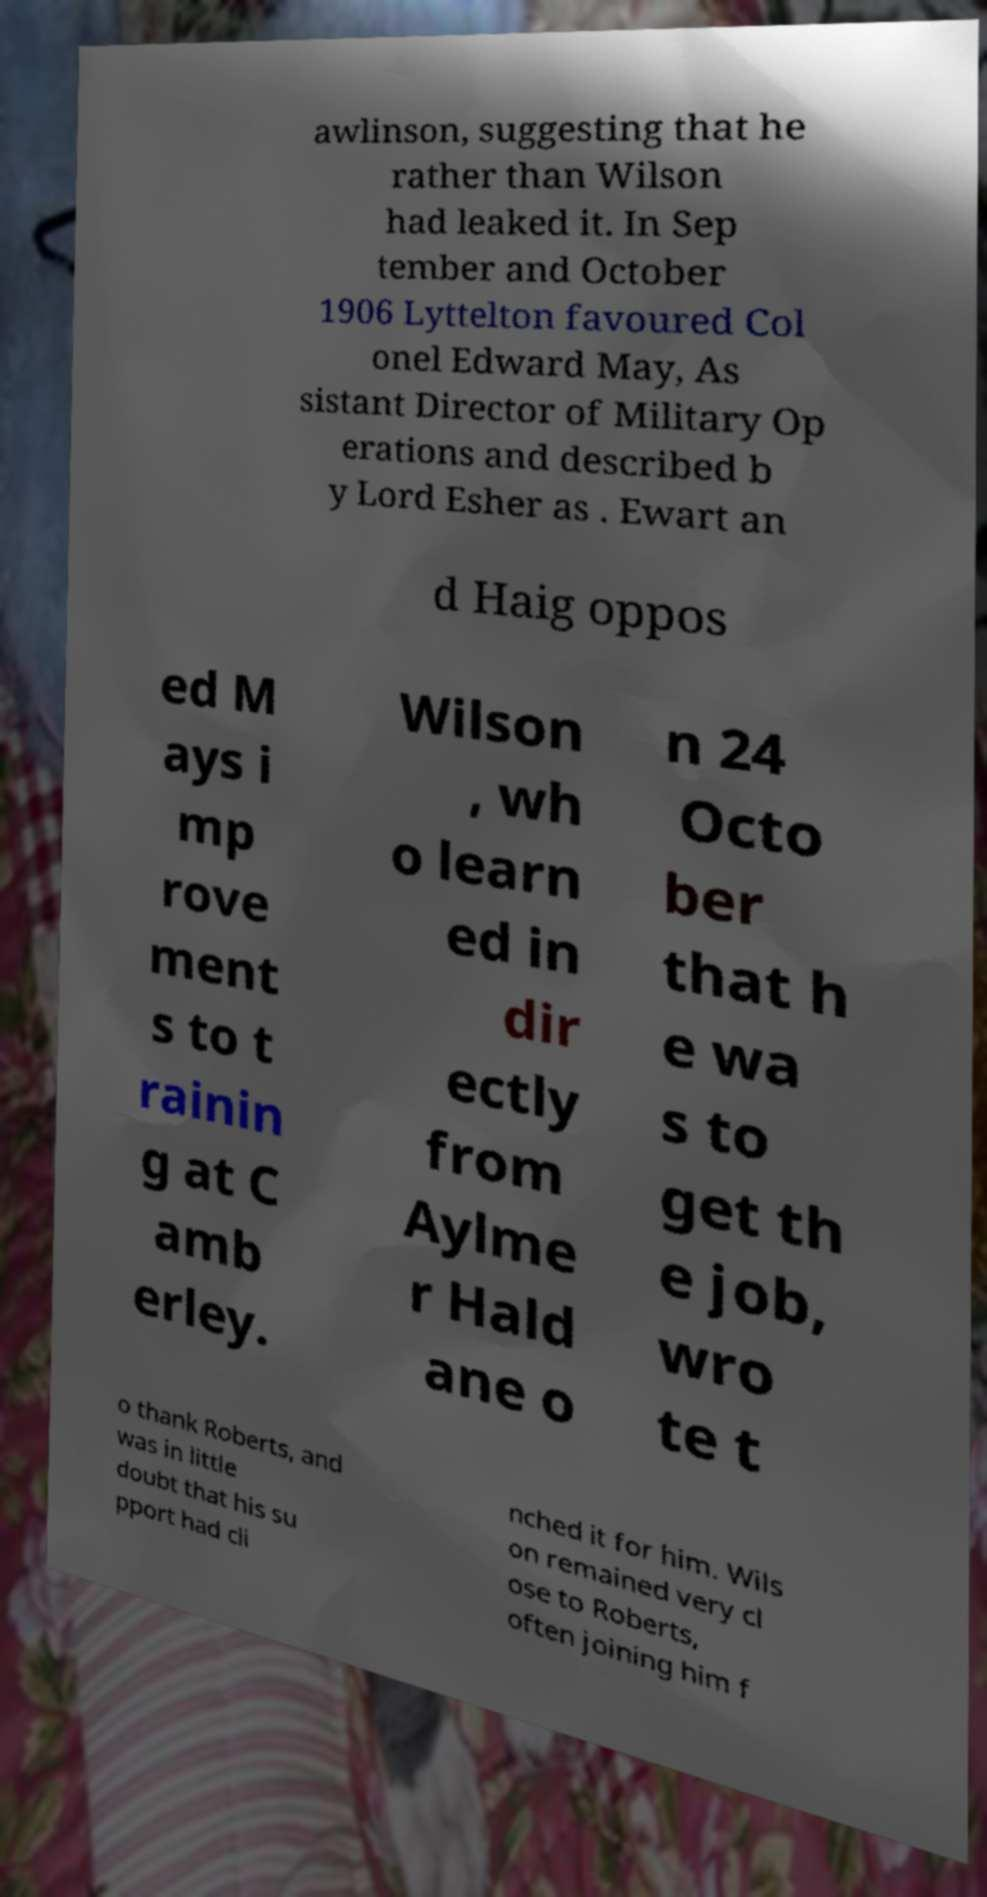Can you read and provide the text displayed in the image?This photo seems to have some interesting text. Can you extract and type it out for me? awlinson, suggesting that he rather than Wilson had leaked it. In Sep tember and October 1906 Lyttelton favoured Col onel Edward May, As sistant Director of Military Op erations and described b y Lord Esher as . Ewart an d Haig oppos ed M ays i mp rove ment s to t rainin g at C amb erley. Wilson , wh o learn ed in dir ectly from Aylme r Hald ane o n 24 Octo ber that h e wa s to get th e job, wro te t o thank Roberts, and was in little doubt that his su pport had cli nched it for him. Wils on remained very cl ose to Roberts, often joining him f 